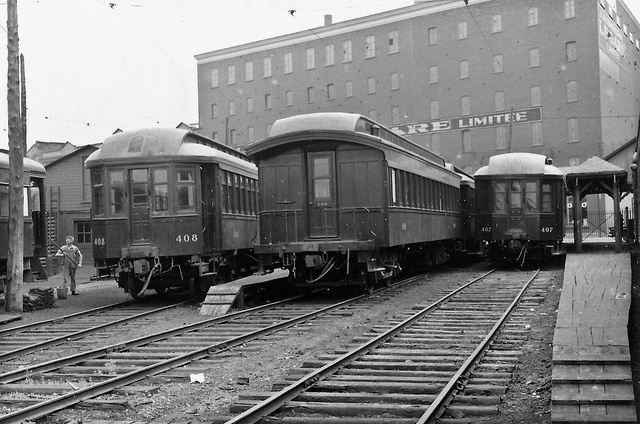Describe the objects in this image and their specific colors. I can see train in white, black, gray, darkgray, and lightgray tones, train in white, gray, black, darkgray, and lightgray tones, train in white, black, gray, lightgray, and darkgray tones, train in white, black, gray, darkgray, and lightgray tones, and people in white, gray, darkgray, black, and lightgray tones in this image. 